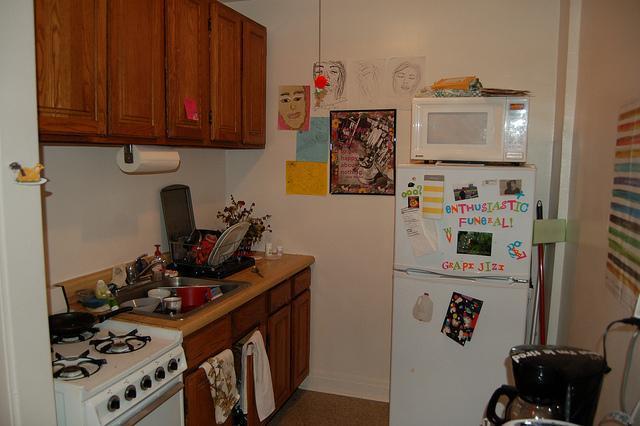How many oven mitts are hanging on cupboards?
Give a very brief answer. 0. How many chairs can be seen?
Give a very brief answer. 0. How many sinks are in the picture?
Give a very brief answer. 1. 